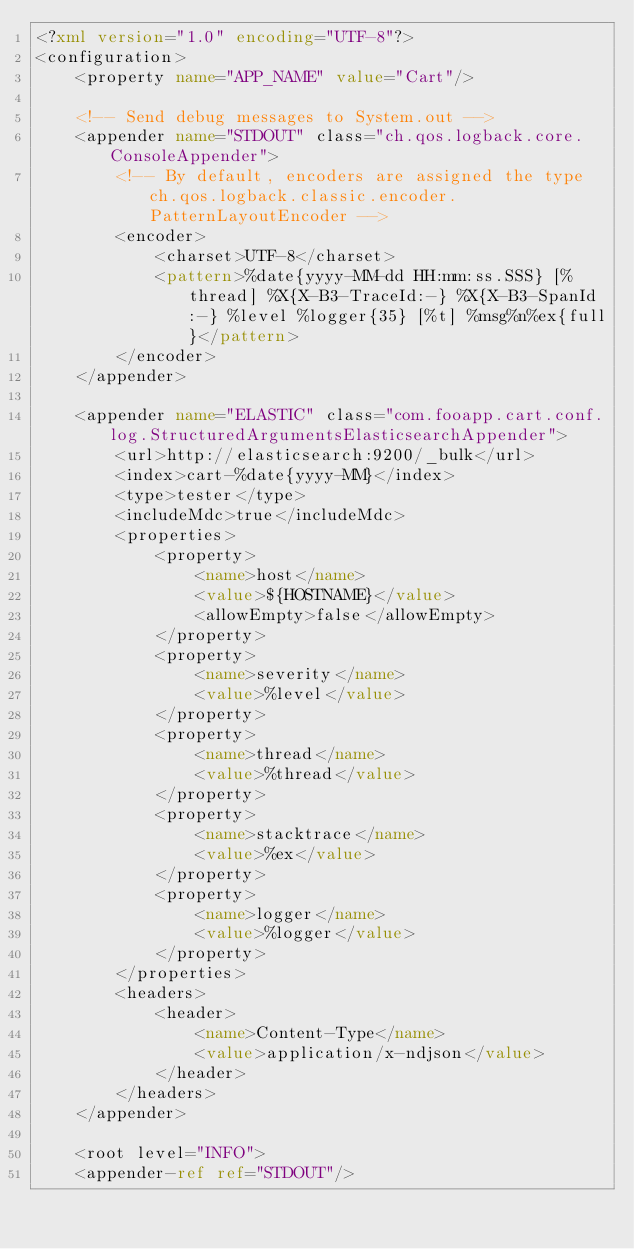<code> <loc_0><loc_0><loc_500><loc_500><_XML_><?xml version="1.0" encoding="UTF-8"?>
<configuration>
    <property name="APP_NAME" value="Cart"/>

    <!-- Send debug messages to System.out -->
    <appender name="STDOUT" class="ch.qos.logback.core.ConsoleAppender">
        <!-- By default, encoders are assigned the type ch.qos.logback.classic.encoder.PatternLayoutEncoder -->
        <encoder>
            <charset>UTF-8</charset>
            <pattern>%date{yyyy-MM-dd HH:mm:ss.SSS} [%thread] %X{X-B3-TraceId:-} %X{X-B3-SpanId:-} %level %logger{35} [%t] %msg%n%ex{full}</pattern>
        </encoder>
    </appender>

    <appender name="ELASTIC" class="com.fooapp.cart.conf.log.StructuredArgumentsElasticsearchAppender">
        <url>http://elasticsearch:9200/_bulk</url>
        <index>cart-%date{yyyy-MM}</index>
        <type>tester</type>
        <includeMdc>true</includeMdc>
        <properties>
            <property>
                <name>host</name>
                <value>${HOSTNAME}</value>
                <allowEmpty>false</allowEmpty>
            </property>
            <property>
                <name>severity</name>
                <value>%level</value>
            </property>
            <property>
                <name>thread</name>
                <value>%thread</value>
            </property>
            <property>
                <name>stacktrace</name>
                <value>%ex</value>
            </property>
            <property>
                <name>logger</name>
                <value>%logger</value>
            </property>
        </properties>
        <headers>
            <header>
                <name>Content-Type</name>
                <value>application/x-ndjson</value>
            </header>
        </headers>
    </appender>

    <root level="INFO">
    <appender-ref ref="STDOUT"/></code> 